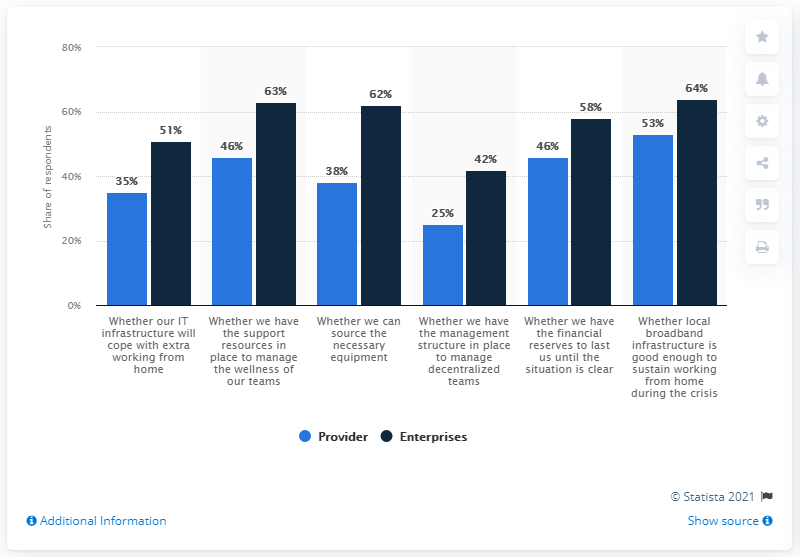Draw attention to some important aspects in this diagram. There are 12 bars visible in the chart. The average of the blue bar is 40.5. 